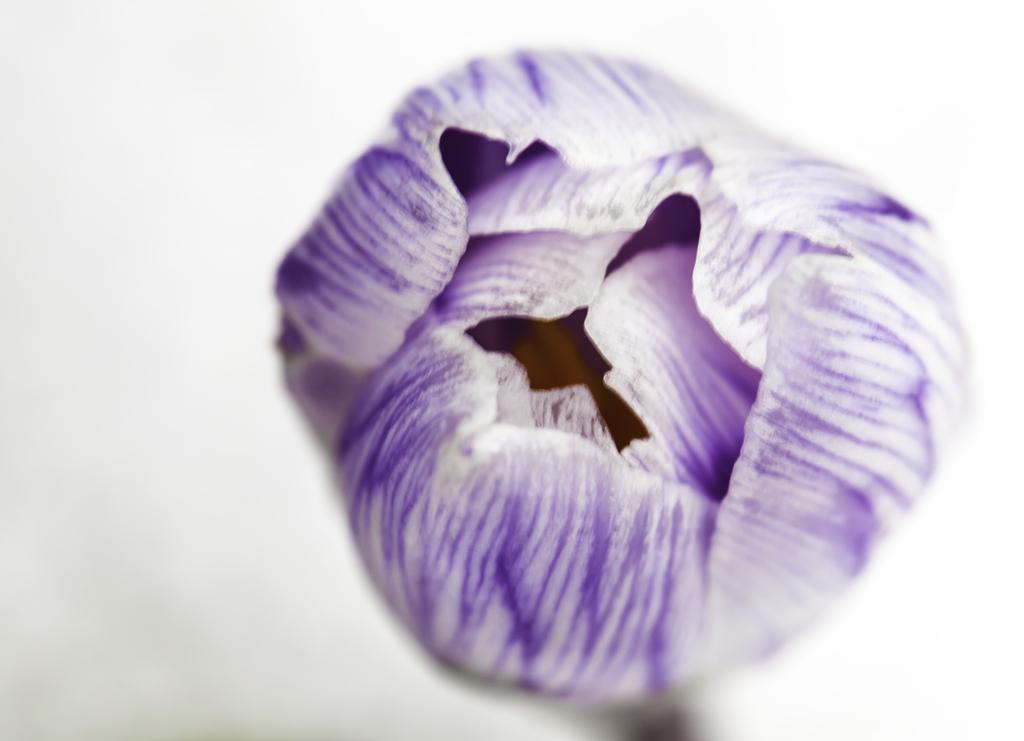What is the main subject of the picture? The main subject of the picture is a flower. What colors are present in the flower's petals? The flower has violet and white petals. How would you describe the background of the image? The background of the image is white and blurred. How many apples are hanging from the flower in the image? There are no apples present in the image; it features a flower with violet and white petals. What type of cable is connected to the flower in the image? There is no cable connected to the flower in the image. 